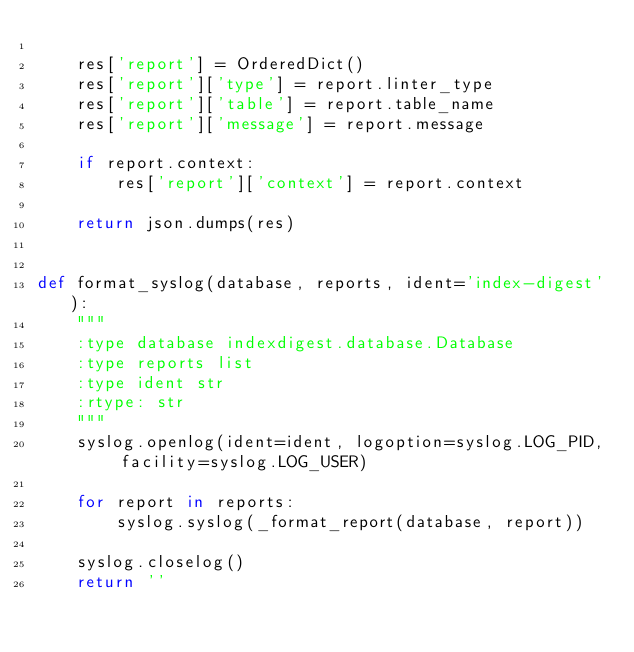Convert code to text. <code><loc_0><loc_0><loc_500><loc_500><_Python_>
    res['report'] = OrderedDict()
    res['report']['type'] = report.linter_type
    res['report']['table'] = report.table_name
    res['report']['message'] = report.message

    if report.context:
        res['report']['context'] = report.context

    return json.dumps(res)


def format_syslog(database, reports, ident='index-digest'):
    """
    :type database indexdigest.database.Database
    :type reports list
    :type ident str
    :rtype: str
    """
    syslog.openlog(ident=ident, logoption=syslog.LOG_PID, facility=syslog.LOG_USER)

    for report in reports:
        syslog.syslog(_format_report(database, report))

    syslog.closelog()
    return ''
</code> 